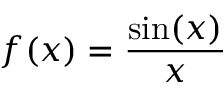Convert formula to latex. <formula><loc_0><loc_0><loc_500><loc_500>f ( x ) = { \frac { \sin ( x ) } { x } }</formula> 